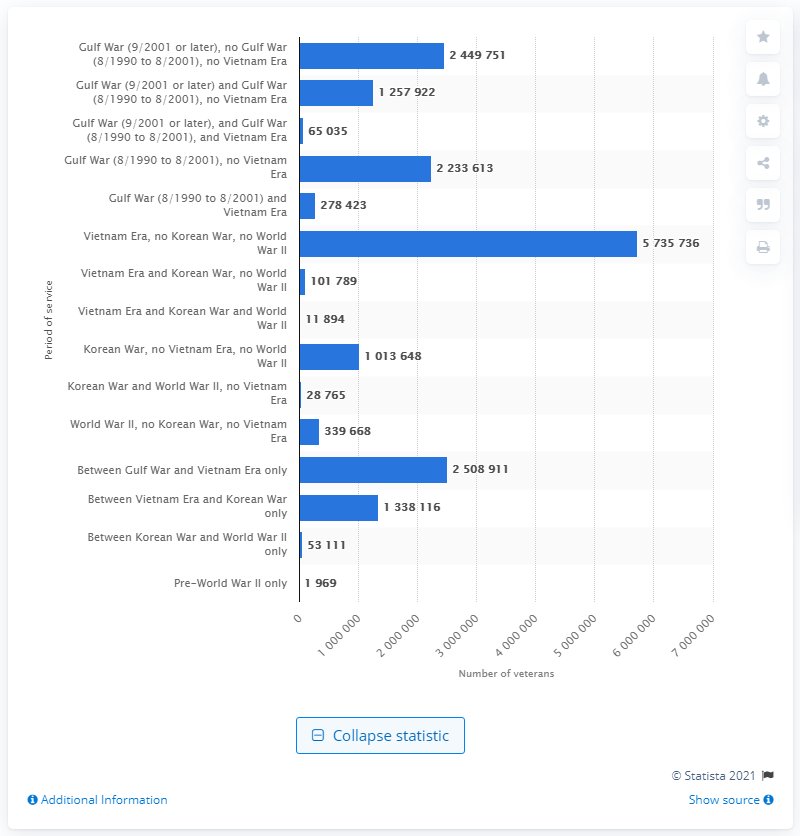Identify some key points in this picture. During the Vietnam Era, a total of 5,735,736 veterans served. 